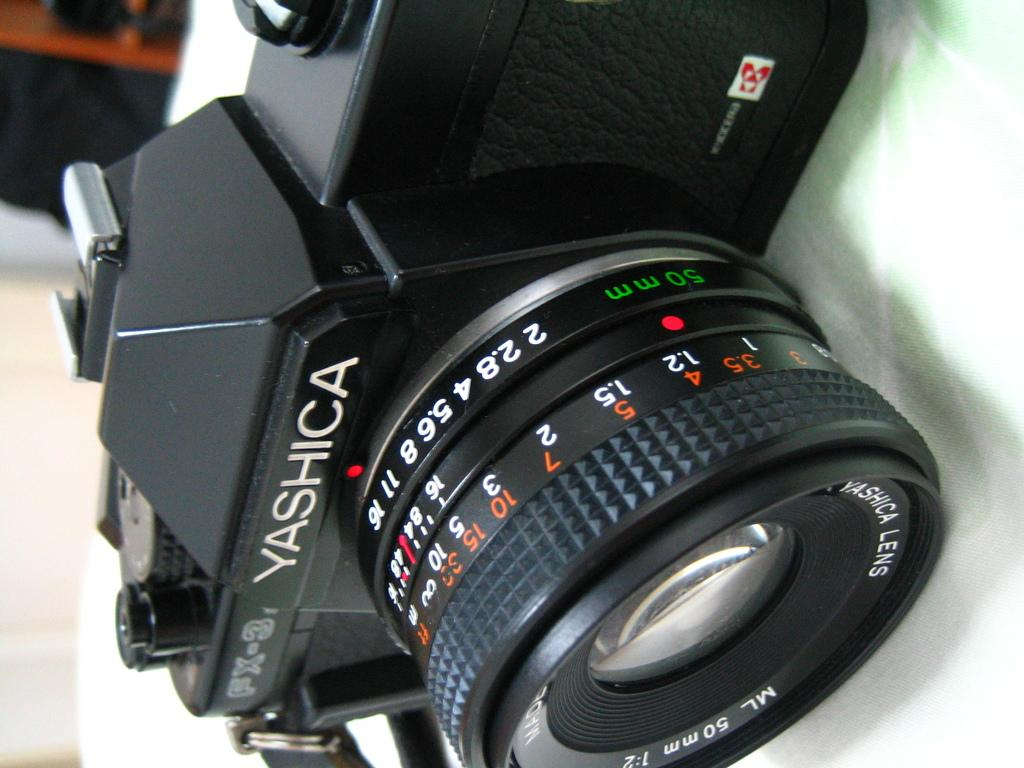What is the main subject of the image? The main subject of the image is a camera. Can you describe the surface on which the camera is placed? The camera is placed on a white surface. What is a specific feature of the camera? The camera has a lens. What are the buttons on the camera used for? The buttons on the camera are used for various functions and settings. What type of roof can be seen on the house in the image? There is no house or roof present in the image; it features a camera placed on a white surface. How many pails are visible in the image? There are no pails present in the image. 